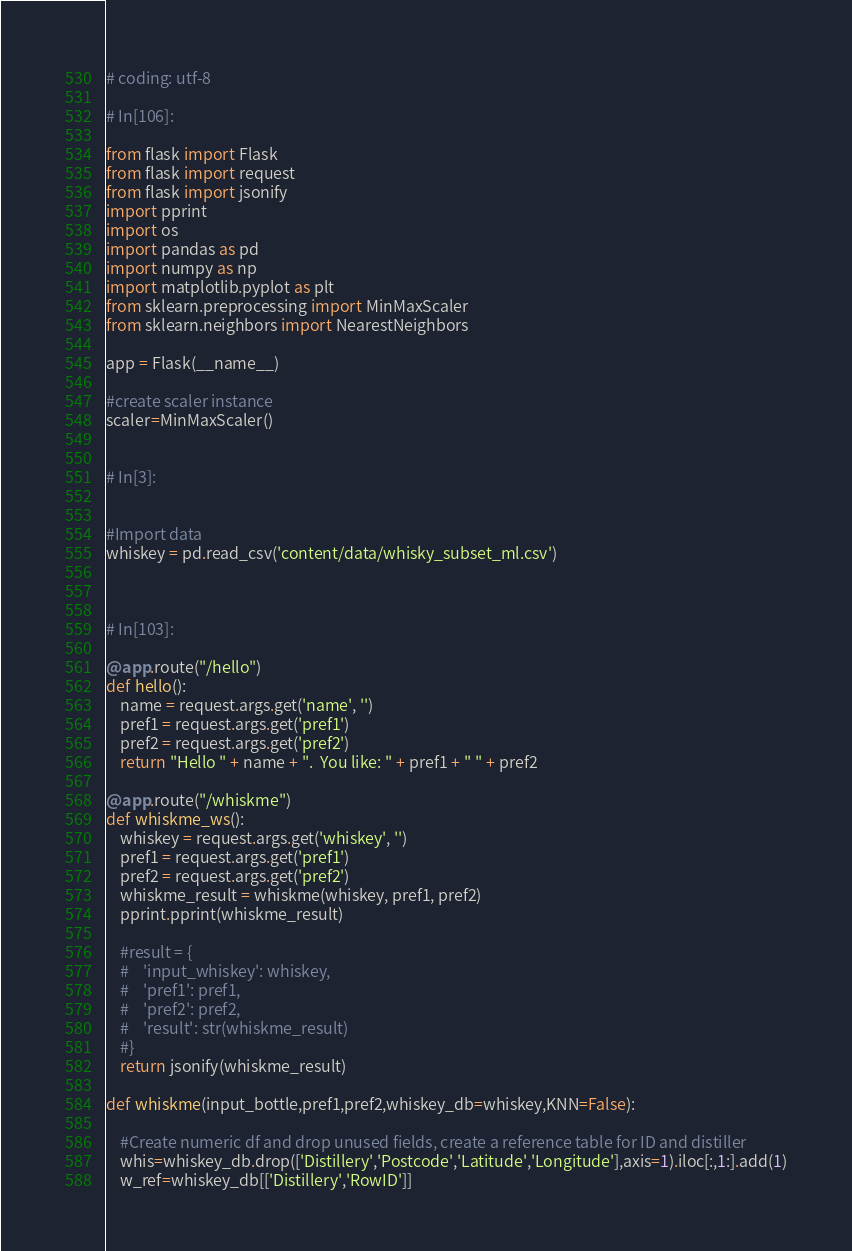<code> <loc_0><loc_0><loc_500><loc_500><_Python_>
# coding: utf-8

# In[106]:

from flask import Flask
from flask import request
from flask import jsonify
import pprint
import os
import pandas as pd
import numpy as np
import matplotlib.pyplot as plt
from sklearn.preprocessing import MinMaxScaler
from sklearn.neighbors import NearestNeighbors

app = Flask(__name__)

#create scaler instance
scaler=MinMaxScaler()


# In[3]:


#Import data
whiskey = pd.read_csv('content/data/whisky_subset_ml.csv')



# In[103]:

@app.route("/hello")
def hello():
    name = request.args.get('name', '')
    pref1 = request.args.get('pref1')
    pref2 = request.args.get('pref2')
    return "Hello " + name + ".  You like: " + pref1 + " " + pref2

@app.route("/whiskme")
def whiskme_ws():
    whiskey = request.args.get('whiskey', '')
    pref1 = request.args.get('pref1')
    pref2 = request.args.get('pref2')
    whiskme_result = whiskme(whiskey, pref1, pref2)
    pprint.pprint(whiskme_result)

    #result = {
    #    'input_whiskey': whiskey,
    #    'pref1': pref1,
    #    'pref2': pref2,
    #    'result': str(whiskme_result)
    #}
    return jsonify(whiskme_result)

def whiskme(input_bottle,pref1,pref2,whiskey_db=whiskey,KNN=False):
        
    #Create numeric df and drop unused fields, create a reference table for ID and distiller
    whis=whiskey_db.drop(['Distillery','Postcode','Latitude','Longitude'],axis=1).iloc[:,1:].add(1)
    w_ref=whiskey_db[['Distillery','RowID']]</code> 